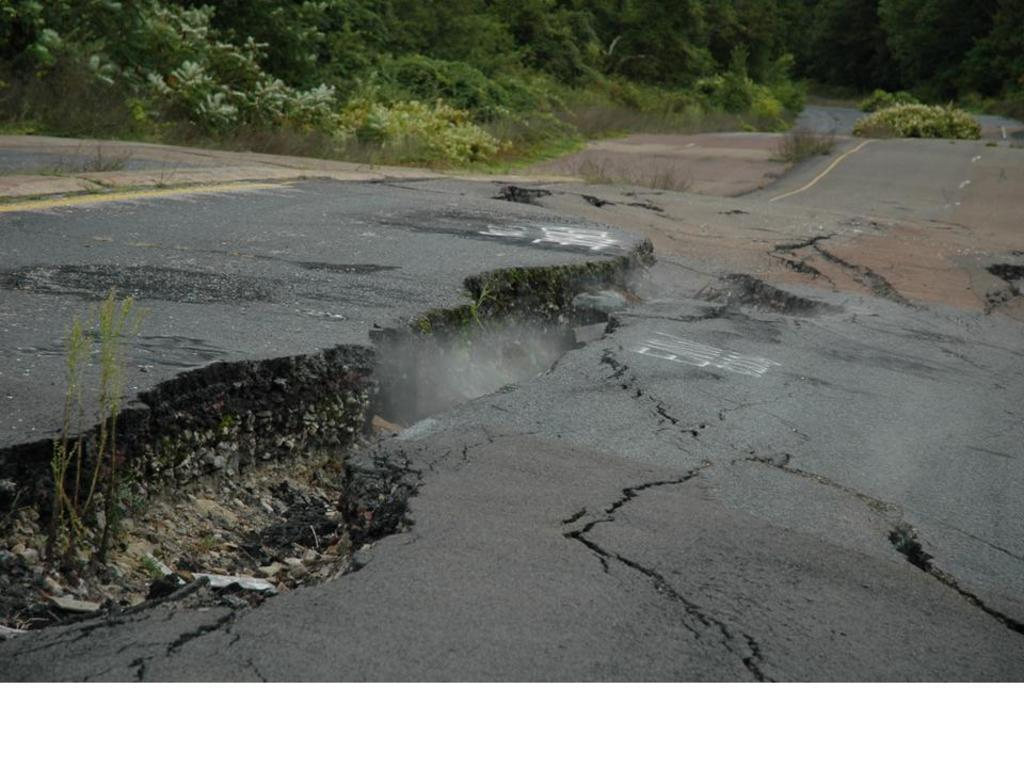What is the condition of the road in the image? The road has cracks in the image. What can be seen on the left side of the road? There are plants on the left side of the road. What is visible in the background of the image? There are plants and trees in the background of the image. How many frogs are sitting on the level of the road in the image? There are no frogs present in the image, and the road is not described as being level. 